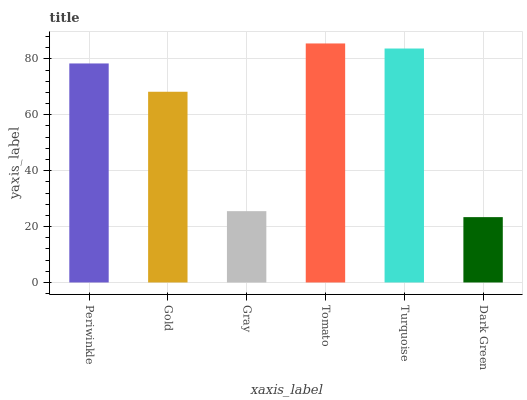Is Dark Green the minimum?
Answer yes or no. Yes. Is Tomato the maximum?
Answer yes or no. Yes. Is Gold the minimum?
Answer yes or no. No. Is Gold the maximum?
Answer yes or no. No. Is Periwinkle greater than Gold?
Answer yes or no. Yes. Is Gold less than Periwinkle?
Answer yes or no. Yes. Is Gold greater than Periwinkle?
Answer yes or no. No. Is Periwinkle less than Gold?
Answer yes or no. No. Is Periwinkle the high median?
Answer yes or no. Yes. Is Gold the low median?
Answer yes or no. Yes. Is Gray the high median?
Answer yes or no. No. Is Periwinkle the low median?
Answer yes or no. No. 